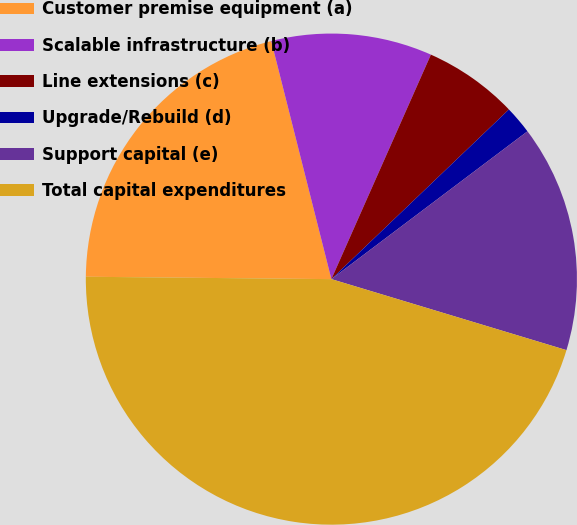Convert chart to OTSL. <chart><loc_0><loc_0><loc_500><loc_500><pie_chart><fcel>Customer premise equipment (a)<fcel>Scalable infrastructure (b)<fcel>Line extensions (c)<fcel>Upgrade/Rebuild (d)<fcel>Support capital (e)<fcel>Total capital expenditures<nl><fcel>20.91%<fcel>10.58%<fcel>6.22%<fcel>1.86%<fcel>14.95%<fcel>45.49%<nl></chart> 